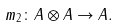<formula> <loc_0><loc_0><loc_500><loc_500>m _ { 2 } \colon A \otimes A \to A .</formula> 